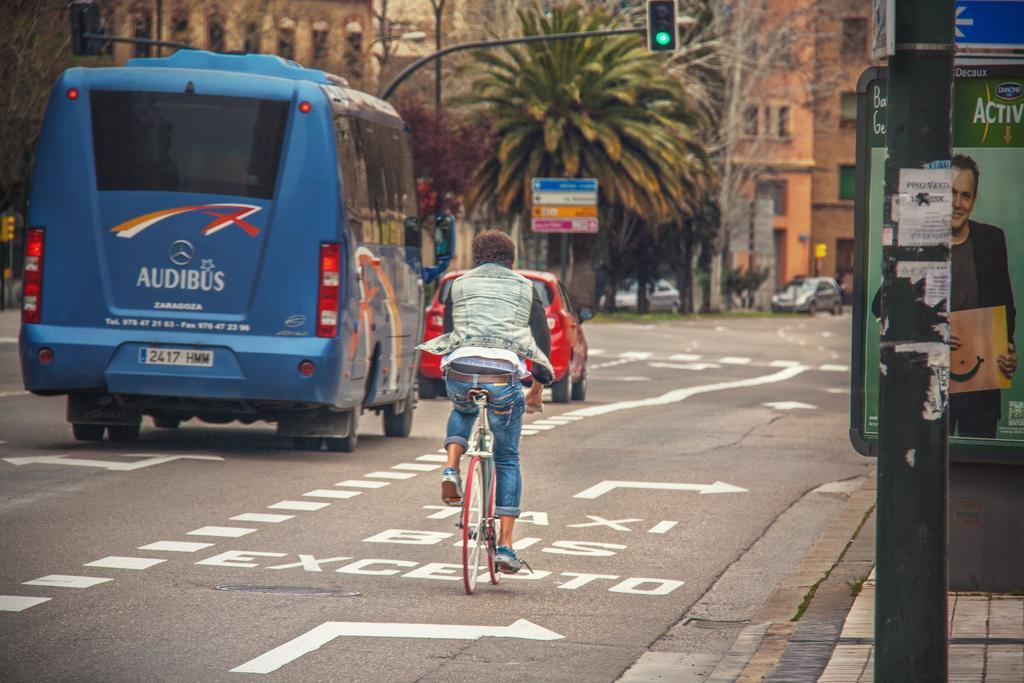Can you describe this image briefly? In this image i can see a person riding bicycle and a bus car and at the background of the image there are buildings and trees. 